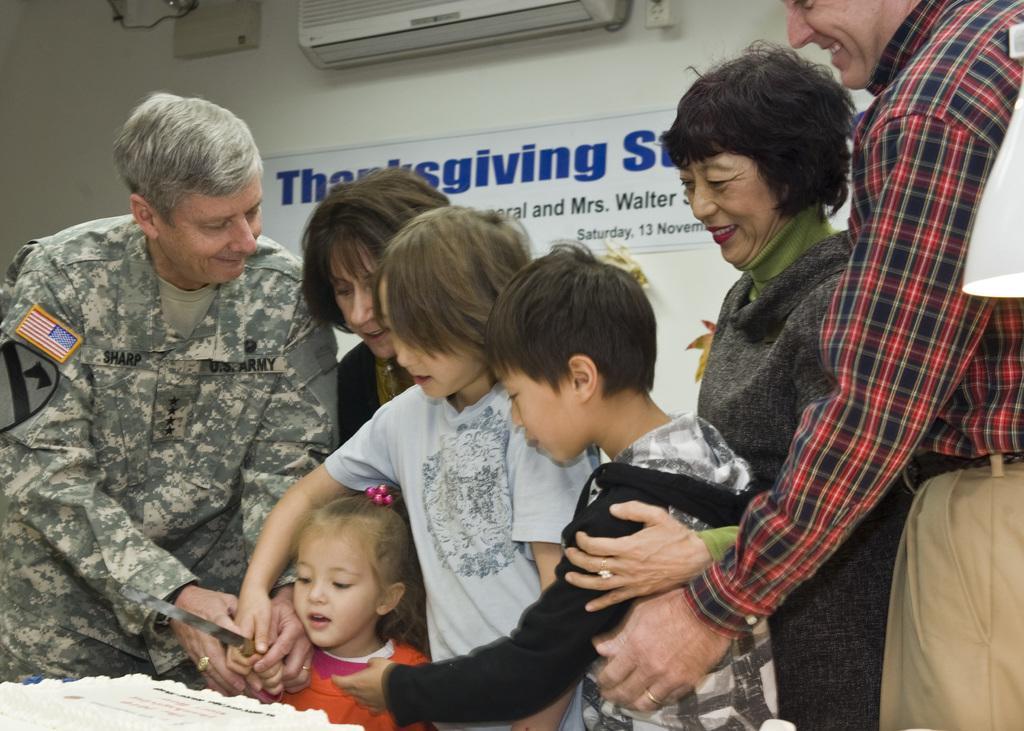Could you give a brief overview of what you see in this image? In this image I can see there are few persons and I can see a baby holding a knife in the bottom left I can see a cake , at the top I can see ac attached to the wall and I can see a notice board attached to the wall in the middle. 